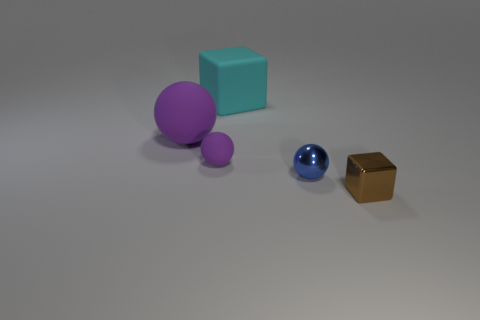Add 5 large purple rubber spheres. How many objects exist? 10 Subtract all balls. How many objects are left? 2 Add 4 large spheres. How many large spheres are left? 5 Add 5 blue metallic balls. How many blue metallic balls exist? 6 Subtract 0 red balls. How many objects are left? 5 Subtract all blocks. Subtract all purple matte objects. How many objects are left? 1 